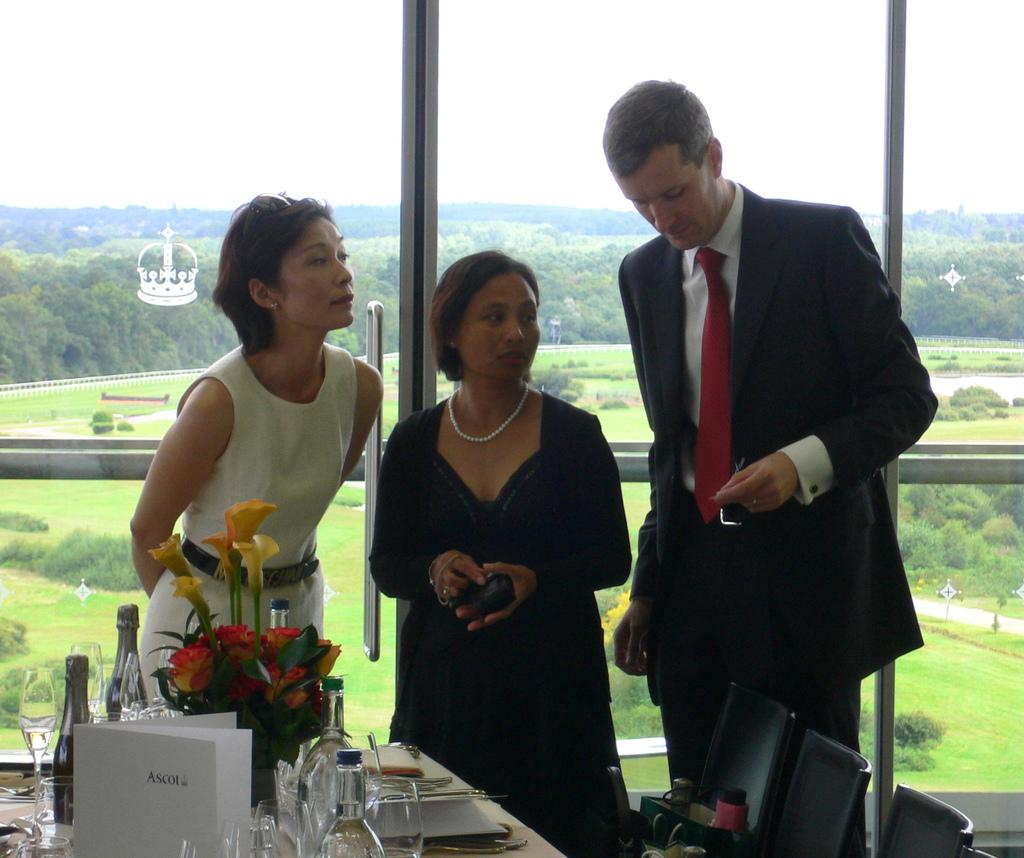How many people are in the image? There are three people in the image. Can you describe the gender of the people? One of the people is a man, and two of the people are women. What objects can be seen on the table? There are bottles, glasses, and a flower vase on the table. What furniture is present around the table? There are chairs around the table. What type of bag is the family using to carry their belongings in the image? There is no bag or family present in the image; it features three people and objects on a table. What action are the people taking in the image? The image does not depict any specific action being taken by the people; they are simply standing or sitting. 